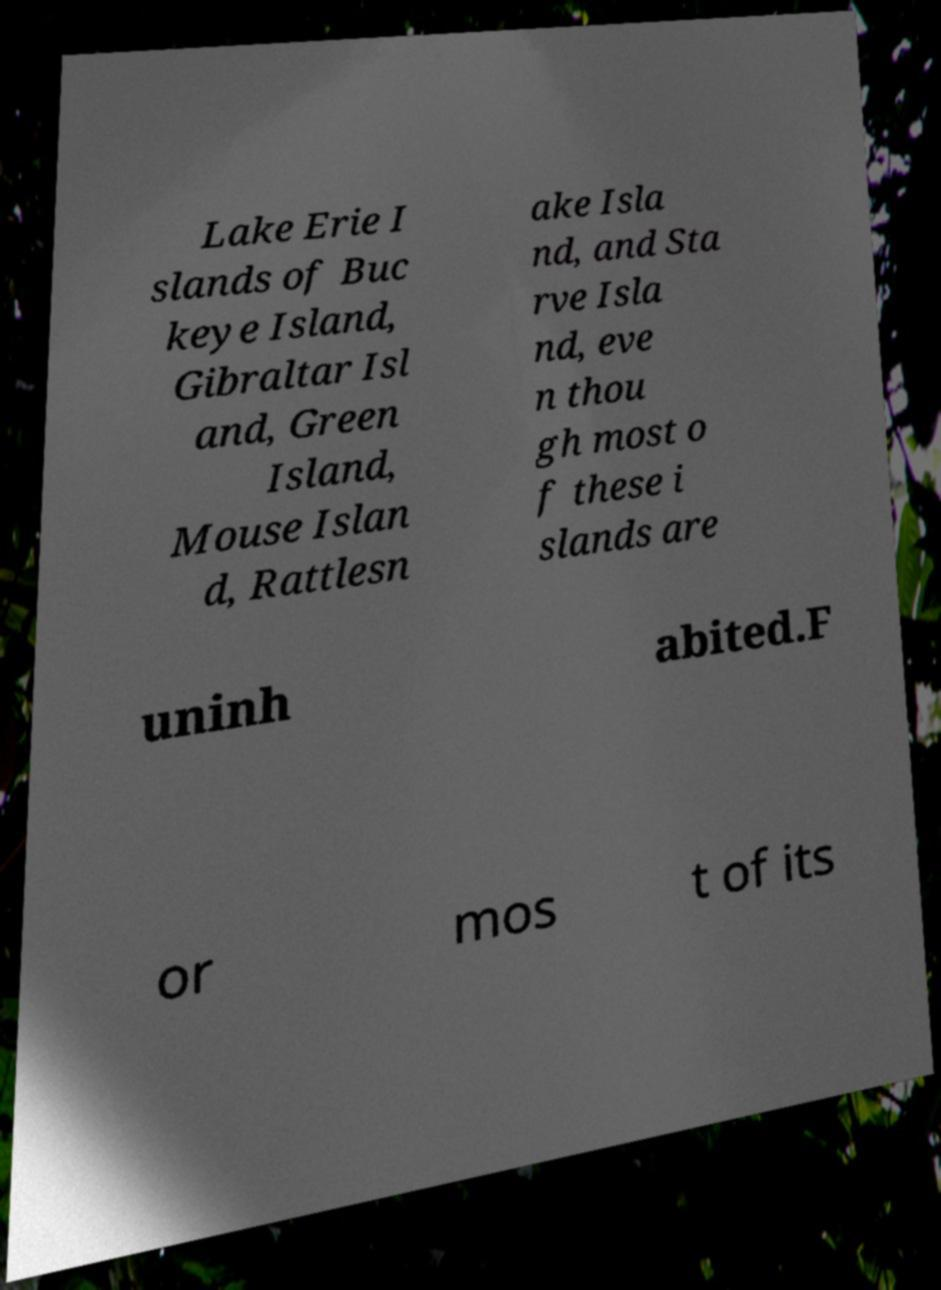What messages or text are displayed in this image? I need them in a readable, typed format. Lake Erie I slands of Buc keye Island, Gibraltar Isl and, Green Island, Mouse Islan d, Rattlesn ake Isla nd, and Sta rve Isla nd, eve n thou gh most o f these i slands are uninh abited.F or mos t of its 